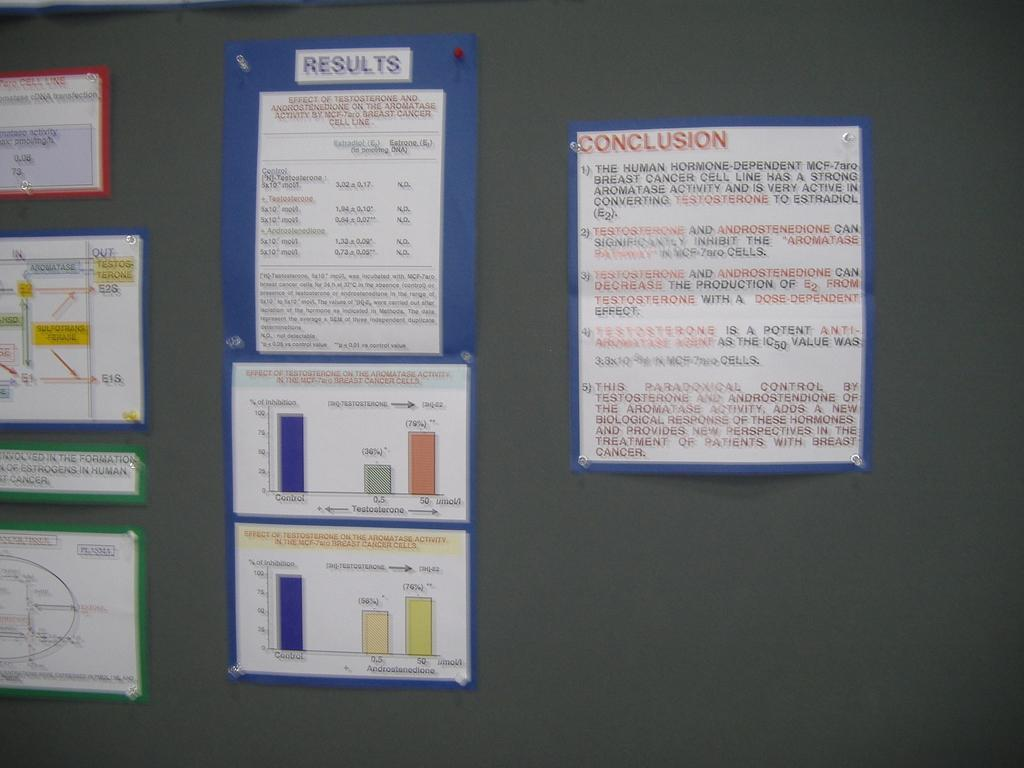Provide a one-sentence caption for the provided image. The papers are attached to a wall with results and conclusions on them. 